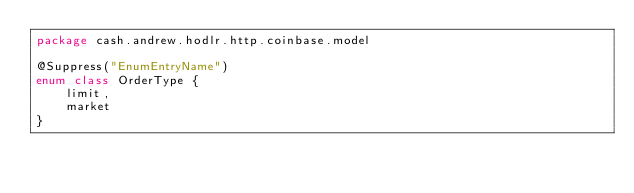<code> <loc_0><loc_0><loc_500><loc_500><_Kotlin_>package cash.andrew.hodlr.http.coinbase.model

@Suppress("EnumEntryName")
enum class OrderType {
    limit,
    market
}</code> 